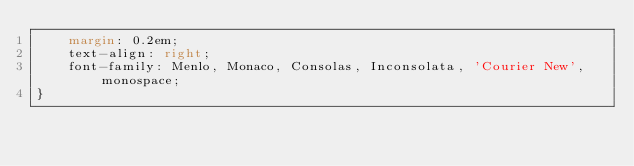Convert code to text. <code><loc_0><loc_0><loc_500><loc_500><_CSS_>    margin: 0.2em;
    text-align: right;
    font-family: Menlo, Monaco, Consolas, Inconsolata, 'Courier New', monospace;
}
</code> 